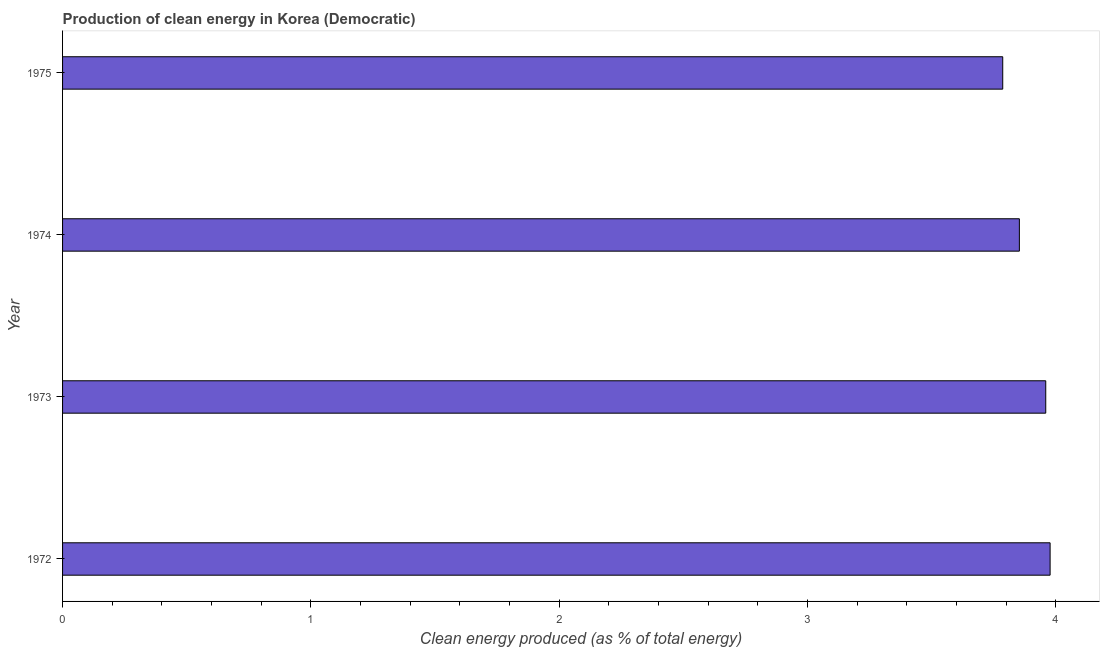Does the graph contain any zero values?
Offer a terse response. No. What is the title of the graph?
Ensure brevity in your answer.  Production of clean energy in Korea (Democratic). What is the label or title of the X-axis?
Give a very brief answer. Clean energy produced (as % of total energy). What is the label or title of the Y-axis?
Your answer should be compact. Year. What is the production of clean energy in 1973?
Provide a succinct answer. 3.96. Across all years, what is the maximum production of clean energy?
Offer a very short reply. 3.98. Across all years, what is the minimum production of clean energy?
Give a very brief answer. 3.79. In which year was the production of clean energy minimum?
Offer a very short reply. 1975. What is the sum of the production of clean energy?
Keep it short and to the point. 15.58. What is the difference between the production of clean energy in 1972 and 1975?
Your answer should be compact. 0.19. What is the average production of clean energy per year?
Your answer should be very brief. 3.89. What is the median production of clean energy?
Give a very brief answer. 3.91. Do a majority of the years between 1974 and 1972 (inclusive) have production of clean energy greater than 0.6 %?
Provide a short and direct response. Yes. What is the ratio of the production of clean energy in 1972 to that in 1974?
Your answer should be very brief. 1.03. Is the production of clean energy in 1972 less than that in 1974?
Make the answer very short. No. Is the difference between the production of clean energy in 1973 and 1975 greater than the difference between any two years?
Make the answer very short. No. What is the difference between the highest and the second highest production of clean energy?
Make the answer very short. 0.02. What is the difference between the highest and the lowest production of clean energy?
Ensure brevity in your answer.  0.19. In how many years, is the production of clean energy greater than the average production of clean energy taken over all years?
Provide a succinct answer. 2. What is the Clean energy produced (as % of total energy) of 1972?
Make the answer very short. 3.98. What is the Clean energy produced (as % of total energy) of 1973?
Offer a very short reply. 3.96. What is the Clean energy produced (as % of total energy) of 1974?
Keep it short and to the point. 3.85. What is the Clean energy produced (as % of total energy) of 1975?
Your answer should be very brief. 3.79. What is the difference between the Clean energy produced (as % of total energy) in 1972 and 1973?
Your answer should be very brief. 0.02. What is the difference between the Clean energy produced (as % of total energy) in 1972 and 1974?
Provide a short and direct response. 0.12. What is the difference between the Clean energy produced (as % of total energy) in 1972 and 1975?
Make the answer very short. 0.19. What is the difference between the Clean energy produced (as % of total energy) in 1973 and 1974?
Give a very brief answer. 0.11. What is the difference between the Clean energy produced (as % of total energy) in 1973 and 1975?
Keep it short and to the point. 0.17. What is the difference between the Clean energy produced (as % of total energy) in 1974 and 1975?
Keep it short and to the point. 0.07. What is the ratio of the Clean energy produced (as % of total energy) in 1972 to that in 1973?
Ensure brevity in your answer.  1. What is the ratio of the Clean energy produced (as % of total energy) in 1972 to that in 1974?
Your answer should be compact. 1.03. What is the ratio of the Clean energy produced (as % of total energy) in 1972 to that in 1975?
Your response must be concise. 1.05. What is the ratio of the Clean energy produced (as % of total energy) in 1973 to that in 1974?
Offer a terse response. 1.03. What is the ratio of the Clean energy produced (as % of total energy) in 1973 to that in 1975?
Make the answer very short. 1.05. 